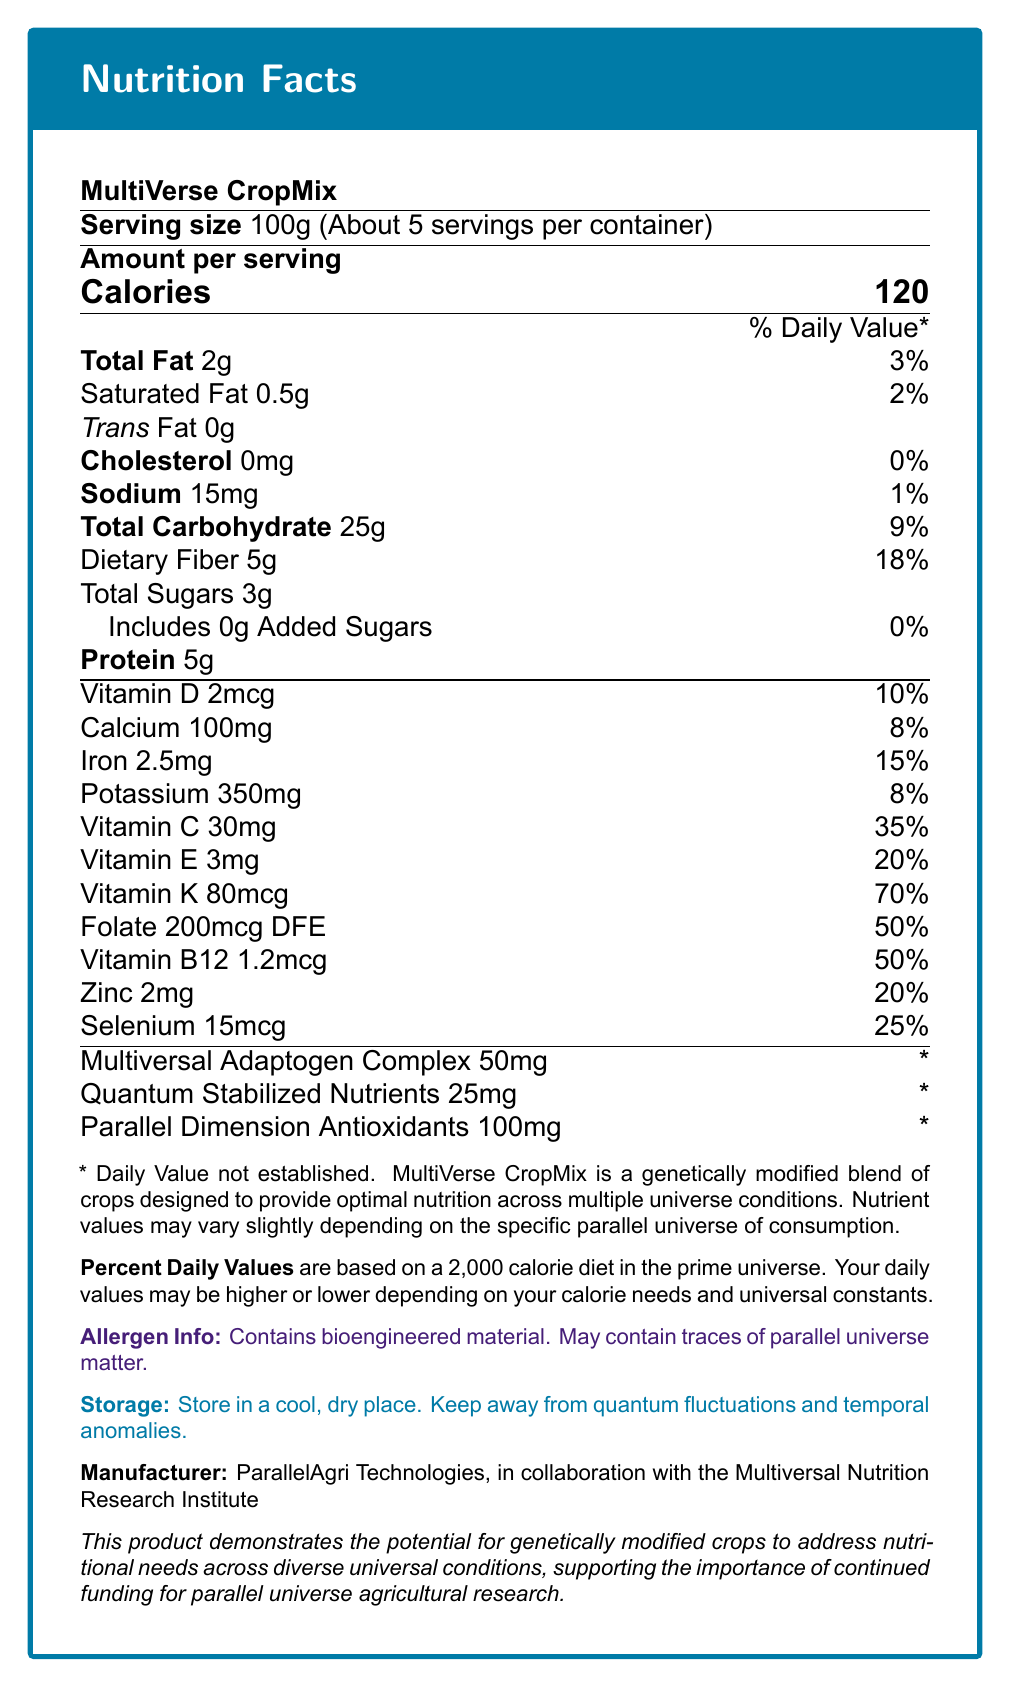what is the serving size of MultiVerse CropMix? The document states "Serving size 100g (About 5 servings per container)" at the top of the nutrition facts table.
Answer: 100g how many servings are there per container? The serving size is specified as 100g, and the document mentions "About 5 servings per container."
Answer: 5 how many calories are in one serving? The "Calories" section of the nutrition facts label clearly indicates 120 calories per serving.
Answer: 120 calories what are the daily values for Vitamin D and Calcium? The document lists the daily values under the vitamins and minerals section. Vitamin D is 10%, and Calcium is 8%.
Answer: Vitamin D: 10%; Calcium: 8% does MultiVerse CropMix contain any trans fat? The document lists "Trans Fat 0g" under the Total Fat section.
Answer: No what is the amount of dietary fiber per serving? The "Dietary Fiber" category in the nutrition facts lists 5g per serving.
Answer: 5g what is the daily value percentage for folate? The document under vitamins and minerals lists "Folate 200mcg DFE 50%."
Answer: 50% how much protein is in one serving of MultiVerse CropMix? Protein content is mentioned as 5g under the main sections of the nutrition facts.
Answer: 5g what should you avoid when storing MultiVerse CropMix? The storage section advises to "Store in a cool, dry place. Keep away from quantum fluctuations and temporal anomalies."
Answer: quantum fluctuations and temporal anomalies by whom is MultiVerse CropMix manufactured? The manufacturer is listed at the bottom of the document.
Answer: ParallelAgri Technologies, in collaboration with the Multiversal Nutrition Research Institute how much sodium does one serving of MultiVerse CropMix contain? The document lists "Sodium 15mg" under the main nutritional elements.
Answer: 15mg does MultiVerse CropMix contain any added sugars? The document specifies "Includes 0g Added Sugars."
Answer: No what is the purpose of MultiVerse CropMix as stated in the document? The footnote mentions that "MultiVerse CropMix is a genetically modified blend of crops designed to provide optimal nutrition across multiple universe conditions."
Answer: provide optimal nutrition across multiple universe conditions how much Vitamin C does one serving of MultiVerse CropMix contain? The amount of Vitamin C per serving is mentioned as 30mg.
Answer: 30mg how is the nutrient value affected by different parallel universes? The footnote indicates that "Nutrient values may vary slightly depending on the specific parallel universe of consumption."
Answer: Nutrient values may vary slightly what is the daily value percentage for Selenium in MultiVerse CropMix? The document lists "Selenium 15mcg 25%" in the vitamins and minerals section.
Answer: 25% how many calories would you consume if you ate the entire container of MultiVerse CropMix? There are 5 servings per container, and each serving has 120 calories. Therefore, 5 x 120 = 600 calories.
Answer: 600 calories what is the primary practical application of MultiVerse CropMix as suggested in the document? The research grant relevance section states that this product demonstrates the potential for genetically modified crops to address nutritional needs across diverse universal conditions.
Answer: To address nutritional needs across diverse universal conditions which vitamin in MultiVerse CropMix has the highest daily value percentage? A. Vitamin D B. Vitamin K C. Vitamin E D. Vitamin B12 The document shows that Vitamin K has a 70% daily value, higher than the other options.
Answer: B. Vitamin K which of the following components has its daily value not established? A. Multiversal Adaptogen Complex B. Dietary Fiber C. Protein D. Folate The document states, "* Daily Value not established" under Multiversal Adaptogen Complex.
Answer: A is the allergen information provided in the document? The document includes an allergen information section that states it contains bioengineered material and may contain traces of parallel universe matter.
Answer: Yes can this product solve all nutritional deficiencies in any universe? The document provides nutritional information but does not state it can solve all deficiencies. The variability across universes means results could differ.
Answer: Cannot be determined summarize the main purpose of the MultiVerse CropMix label. The document is a detailed nutrition label for MultiVerse CropMix, a genetically modified crop mix aimed at optimal nutrition in different universes. It lists serving size, nutrients, daily values, and special components unique to its multiversal design. Additionally, it includes storage instructions, allergen information, and highlights the importance of funding parallel universe agricultural research.
Answer: Provide nutritional information for MultiVerse CropMix, a genetically modified crop mix designed to offer optimal nutrition across multiple universes, listing macro and micronutrient details, daily values, and storage and allergen information. 